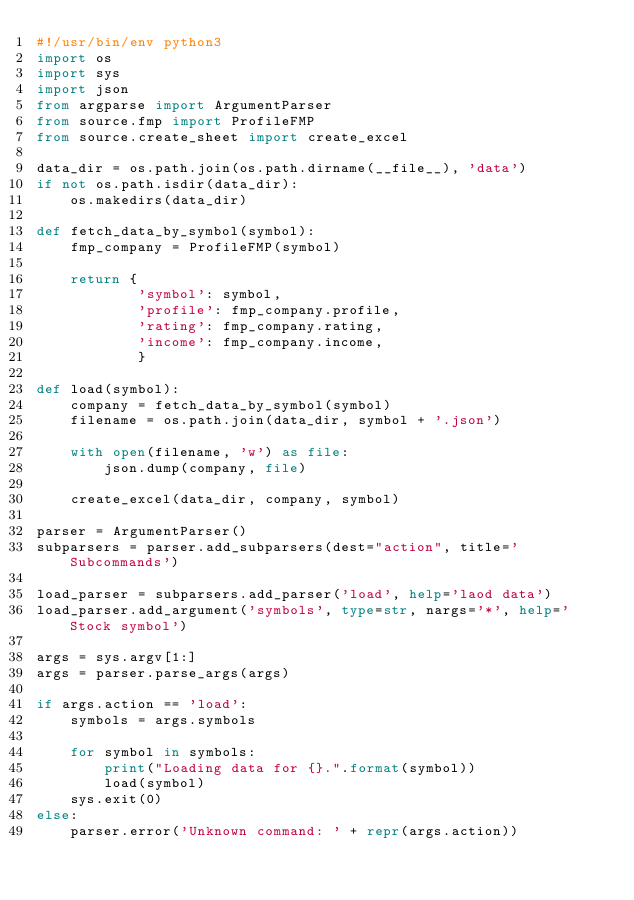Convert code to text. <code><loc_0><loc_0><loc_500><loc_500><_Python_>#!/usr/bin/env python3
import os
import sys
import json
from argparse import ArgumentParser
from source.fmp import ProfileFMP
from source.create_sheet import create_excel

data_dir = os.path.join(os.path.dirname(__file__), 'data')
if not os.path.isdir(data_dir):
    os.makedirs(data_dir)

def fetch_data_by_symbol(symbol):
    fmp_company = ProfileFMP(symbol)
    
    return {
            'symbol': symbol,
            'profile': fmp_company.profile,
            'rating': fmp_company.rating,
            'income': fmp_company.income,
            }

def load(symbol):
    company = fetch_data_by_symbol(symbol)
    filename = os.path.join(data_dir, symbol + '.json')
    
    with open(filename, 'w') as file:
        json.dump(company, file)

    create_excel(data_dir, company, symbol)

parser = ArgumentParser()
subparsers = parser.add_subparsers(dest="action", title='Subcommands')

load_parser = subparsers.add_parser('load', help='laod data')
load_parser.add_argument('symbols', type=str, nargs='*', help='Stock symbol')

args = sys.argv[1:]
args = parser.parse_args(args)

if args.action == 'load':
    symbols = args.symbols

    for symbol in symbols:
        print("Loading data for {}.".format(symbol))
        load(symbol)
    sys.exit(0)
else:
    parser.error('Unknown command: ' + repr(args.action))
</code> 